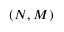Convert formula to latex. <formula><loc_0><loc_0><loc_500><loc_500>( N , M )</formula> 